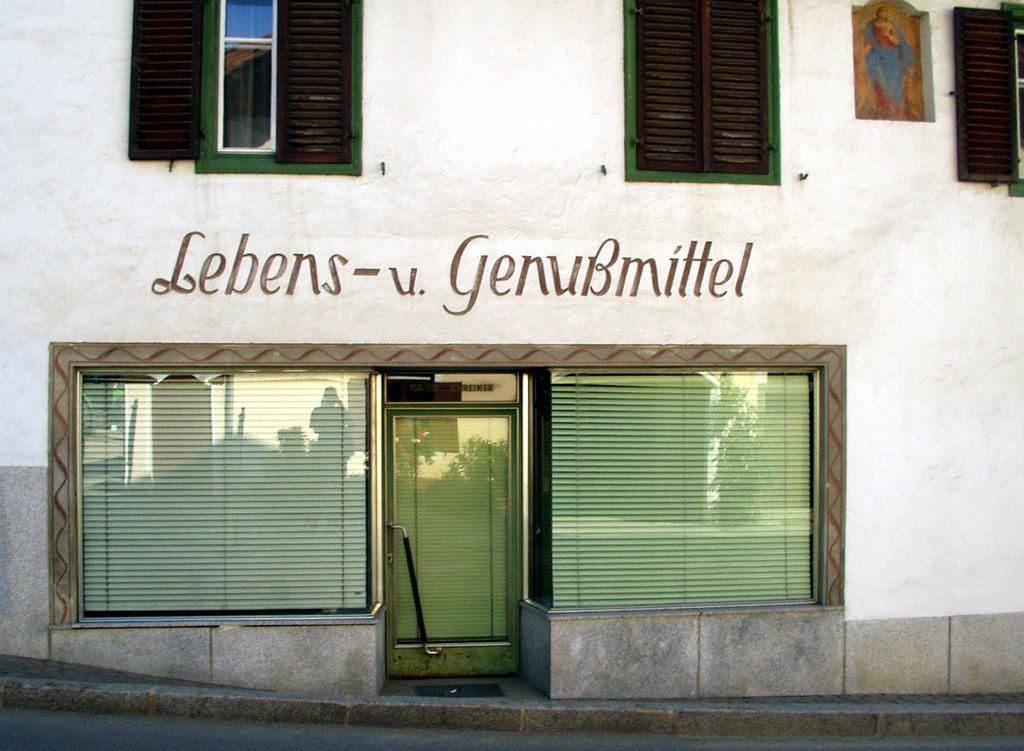Describe this image in one or two sentences. In this image there is a building for that building, there are windows and a door and there is some text. 